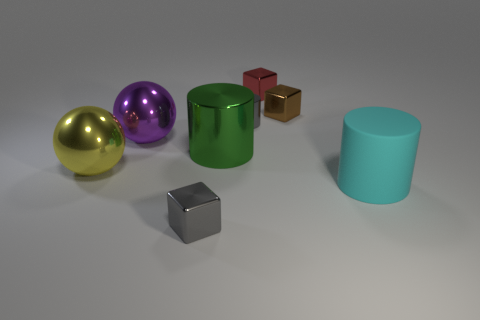Add 2 big yellow metal balls. How many objects exist? 10 Subtract all cubes. How many objects are left? 5 Add 3 large metallic objects. How many large metallic objects exist? 6 Subtract 1 green cylinders. How many objects are left? 7 Subtract all small cyan rubber balls. Subtract all purple metallic things. How many objects are left? 7 Add 7 small blocks. How many small blocks are left? 10 